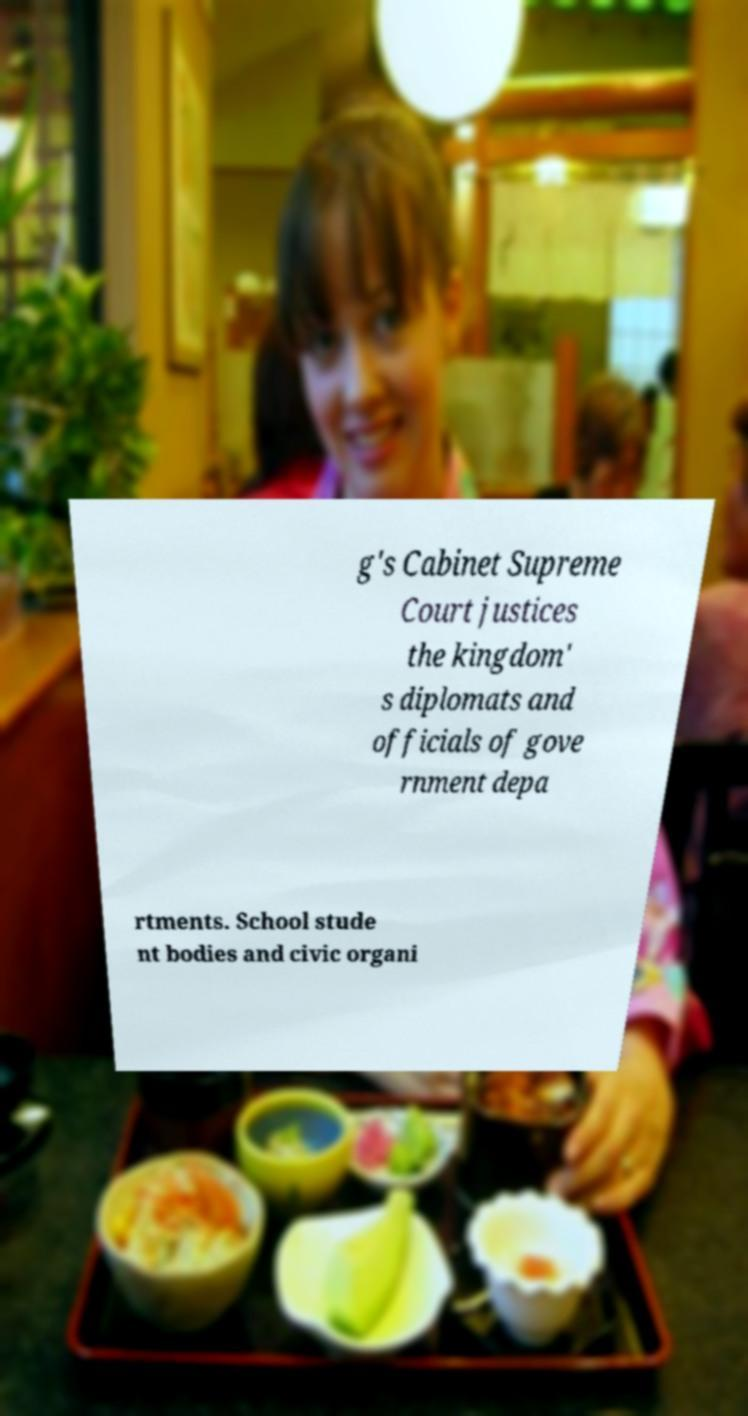I need the written content from this picture converted into text. Can you do that? g's Cabinet Supreme Court justices the kingdom' s diplomats and officials of gove rnment depa rtments. School stude nt bodies and civic organi 